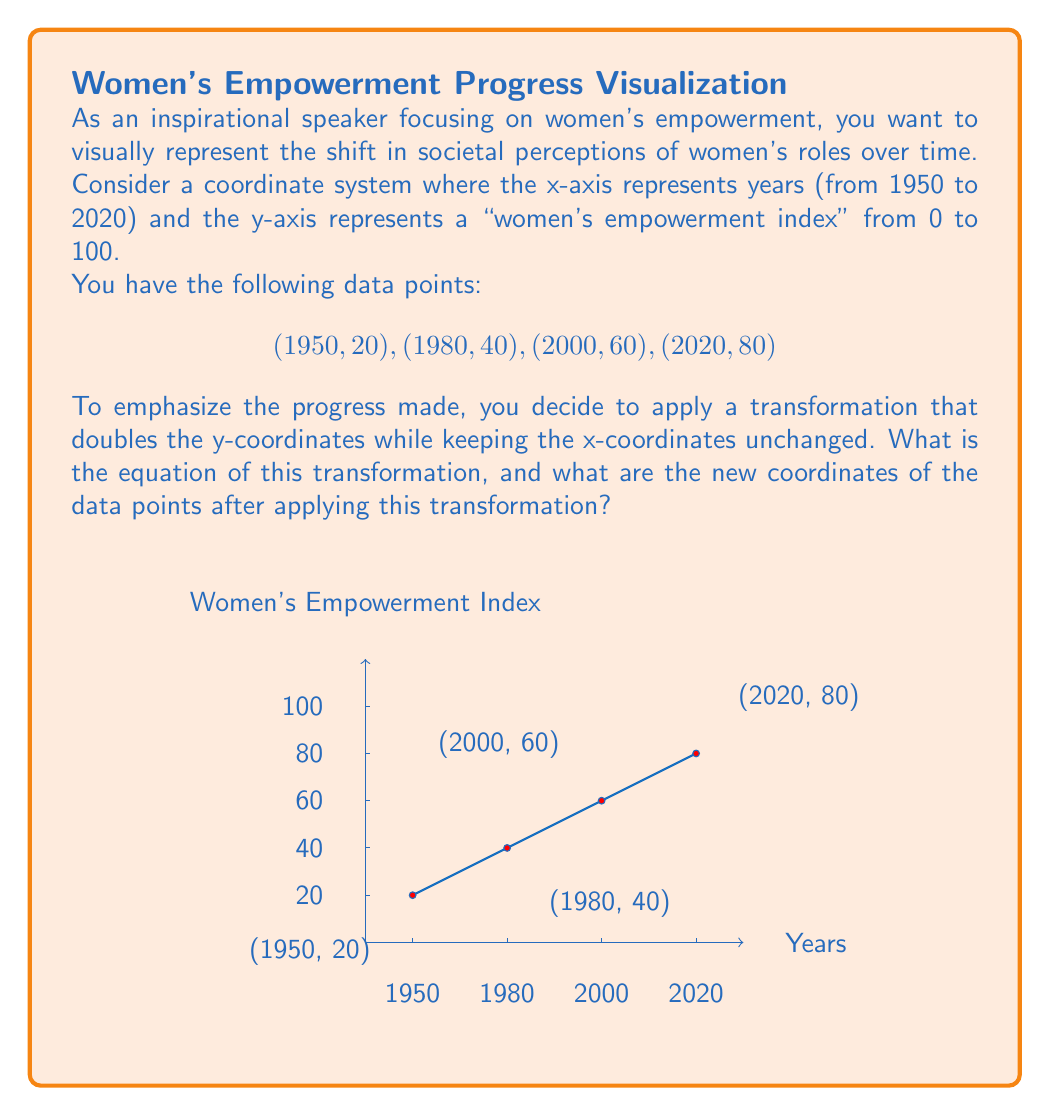Could you help me with this problem? Let's approach this step-by-step:

1) The transformation doubles the y-coordinates while keeping the x-coordinates unchanged. This can be represented mathematically as:

   $$(x, y) \rightarrow (x, 2y)$$

2) Therefore, the equation of this transformation is:
   
   $$T(x,y) = (x, 2y)$$

3) Now, let's apply this transformation to each of our data points:

   a) For (1950, 20):
      $T(1950, 20) = (1950, 2(20)) = (1950, 40)$

   b) For (1980, 40):
      $T(1980, 40) = (1980, 2(40)) = (1980, 80)$

   c) For (2000, 60):
      $T(2000, 60) = (2000, 2(60)) = (2000, 120)$

   d) For (2020, 80):
      $T(2020, 80) = (2020, 2(80)) = (2020, 160)$

4) The new set of coordinates after the transformation is:
   (1950, 40), (1980, 80), (2000, 120), (2020, 160)

This transformation visually emphasizes the progress in women's empowerment by stretching the graph vertically, making the upward trend more pronounced.
Answer: $T(x,y) = (x, 2y)$; New coordinates: (1950, 40), (1980, 80), (2000, 120), (2020, 160) 